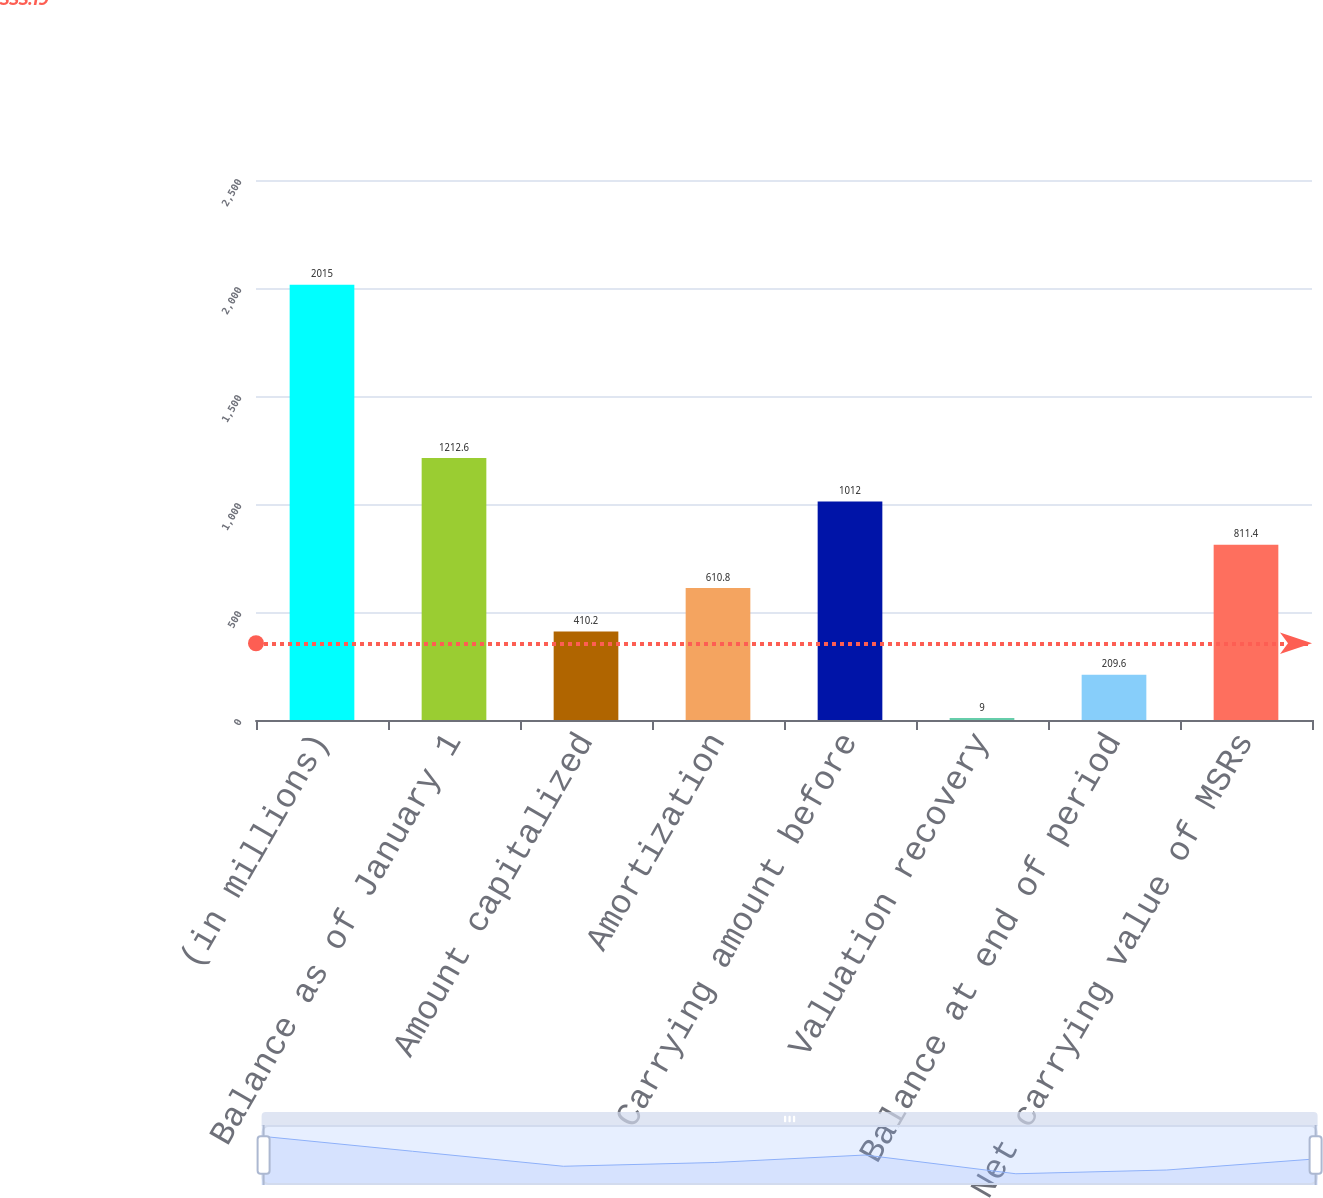Convert chart to OTSL. <chart><loc_0><loc_0><loc_500><loc_500><bar_chart><fcel>(in millions)<fcel>Balance as of January 1<fcel>Amount capitalized<fcel>Amortization<fcel>Carrying amount before<fcel>Valuation recovery<fcel>Balance at end of period<fcel>Net carrying value of MSRs<nl><fcel>2015<fcel>1212.6<fcel>410.2<fcel>610.8<fcel>1012<fcel>9<fcel>209.6<fcel>811.4<nl></chart> 